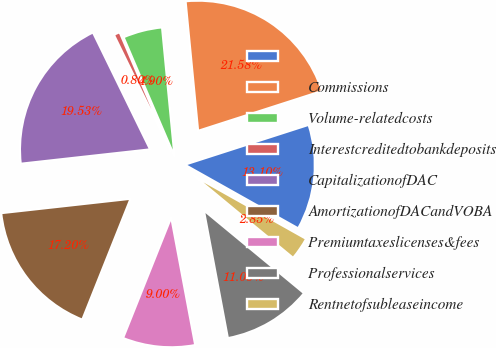<chart> <loc_0><loc_0><loc_500><loc_500><pie_chart><ecel><fcel>Commissions<fcel>Volume-relatedcosts<fcel>Interestcreditedtobankdeposits<fcel>CapitalizationofDAC<fcel>AmortizationofDACandVOBA<fcel>Premiumtaxeslicenses&fees<fcel>Professionalservices<fcel>Rentnetofsubleaseincome<nl><fcel>13.1%<fcel>21.58%<fcel>4.9%<fcel>0.8%<fcel>19.53%<fcel>17.2%<fcel>9.0%<fcel>11.05%<fcel>2.85%<nl></chart> 